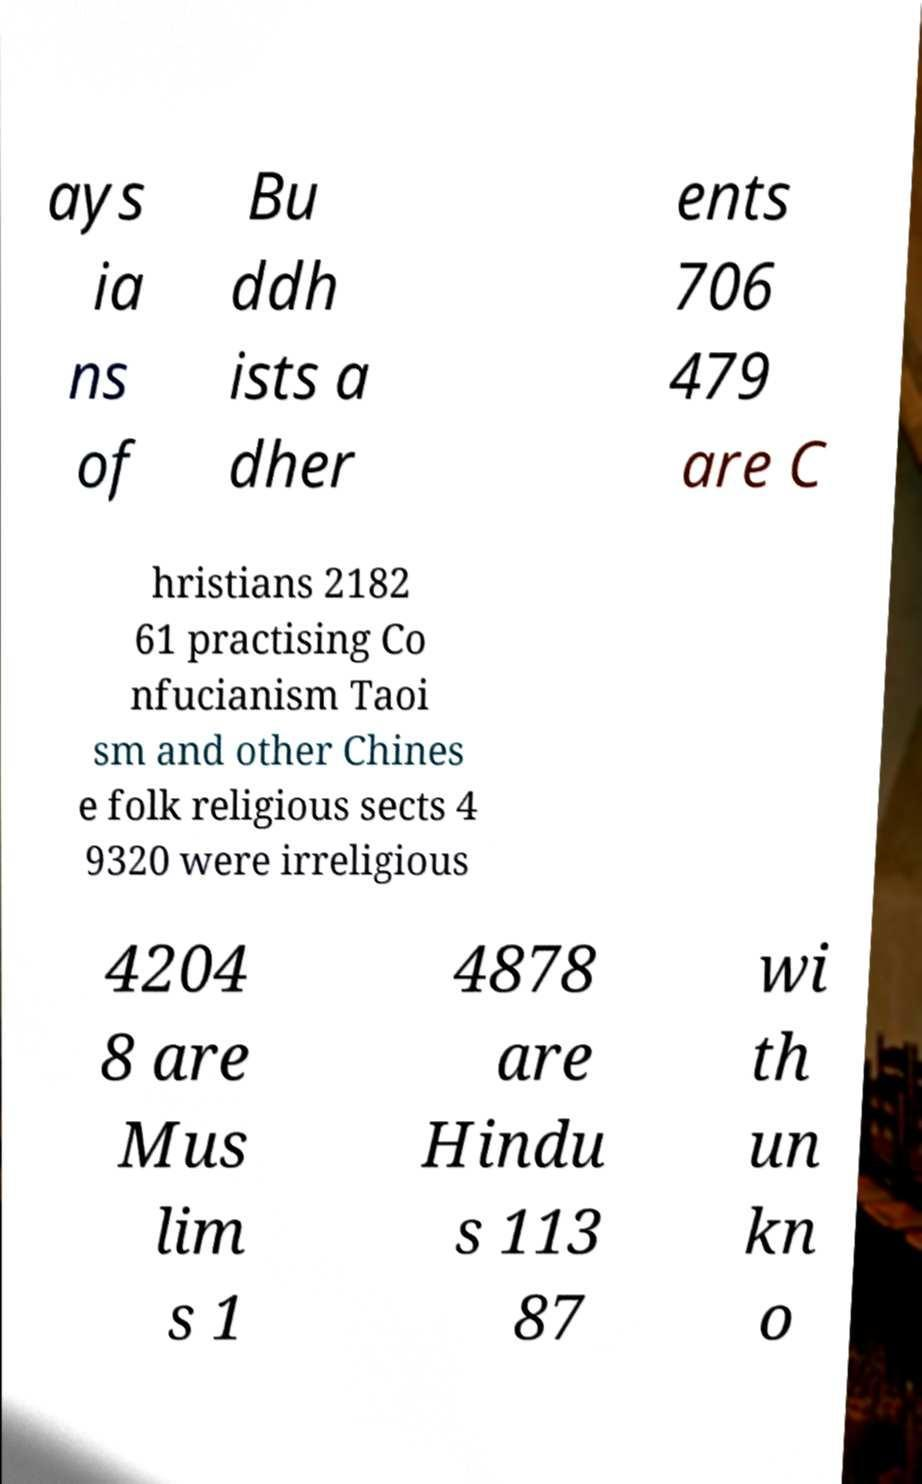There's text embedded in this image that I need extracted. Can you transcribe it verbatim? ays ia ns of Bu ddh ists a dher ents 706 479 are C hristians 2182 61 practising Co nfucianism Taoi sm and other Chines e folk religious sects 4 9320 were irreligious 4204 8 are Mus lim s 1 4878 are Hindu s 113 87 wi th un kn o 